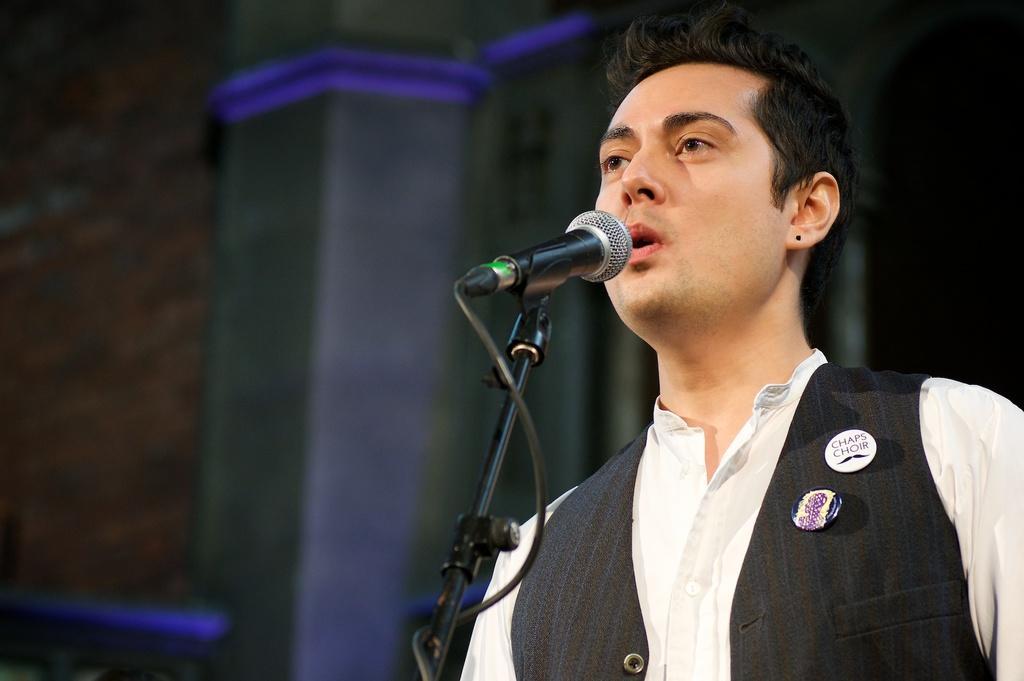How would you summarize this image in a sentence or two? In this image we can see a person standing in front of the mic and in the background we can see the pillars. 